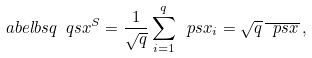Convert formula to latex. <formula><loc_0><loc_0><loc_500><loc_500>\sl a b e l { b s q } \ q s x ^ { S } = \frac { 1 } { \sqrt { q } } \sum _ { i = 1 } ^ { q } \ p s x _ { i } = \sqrt { q } \, \overline { \ p s x } \, ,</formula> 